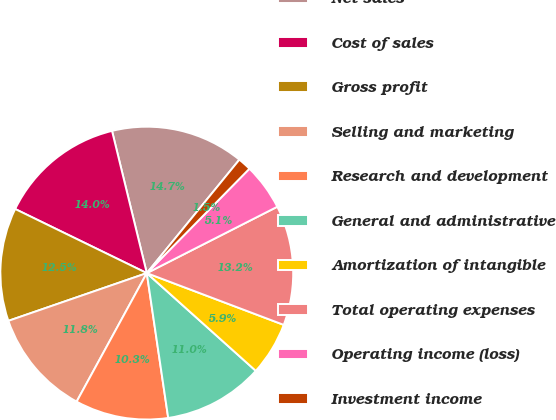Convert chart to OTSL. <chart><loc_0><loc_0><loc_500><loc_500><pie_chart><fcel>Net sales<fcel>Cost of sales<fcel>Gross profit<fcel>Selling and marketing<fcel>Research and development<fcel>General and administrative<fcel>Amortization of intangible<fcel>Total operating expenses<fcel>Operating income (loss)<fcel>Investment income<nl><fcel>14.71%<fcel>13.97%<fcel>12.5%<fcel>11.76%<fcel>10.29%<fcel>11.03%<fcel>5.88%<fcel>13.24%<fcel>5.15%<fcel>1.47%<nl></chart> 